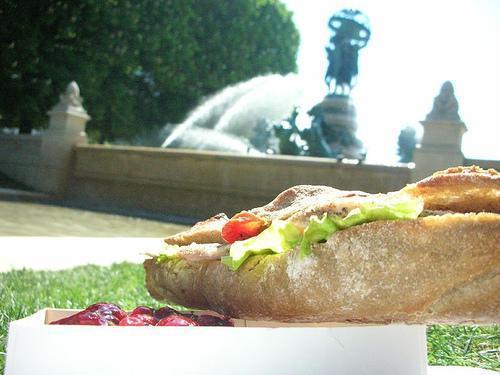How many sandwiches are there?
Give a very brief answer. 1. 